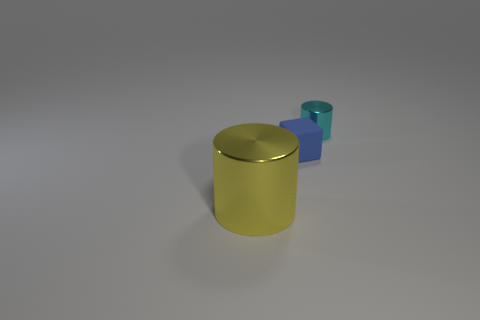Add 1 large shiny cylinders. How many objects exist? 4 Subtract all cyan cylinders. How many cylinders are left? 1 Subtract all blocks. How many objects are left? 2 Subtract 1 cubes. How many cubes are left? 0 Subtract all gray cylinders. Subtract all green balls. How many cylinders are left? 2 Subtract all yellow balls. How many red cylinders are left? 0 Subtract all small purple metallic blocks. Subtract all small cyan objects. How many objects are left? 2 Add 1 tiny shiny things. How many tiny shiny things are left? 2 Add 3 green rubber cylinders. How many green rubber cylinders exist? 3 Subtract 0 purple blocks. How many objects are left? 3 